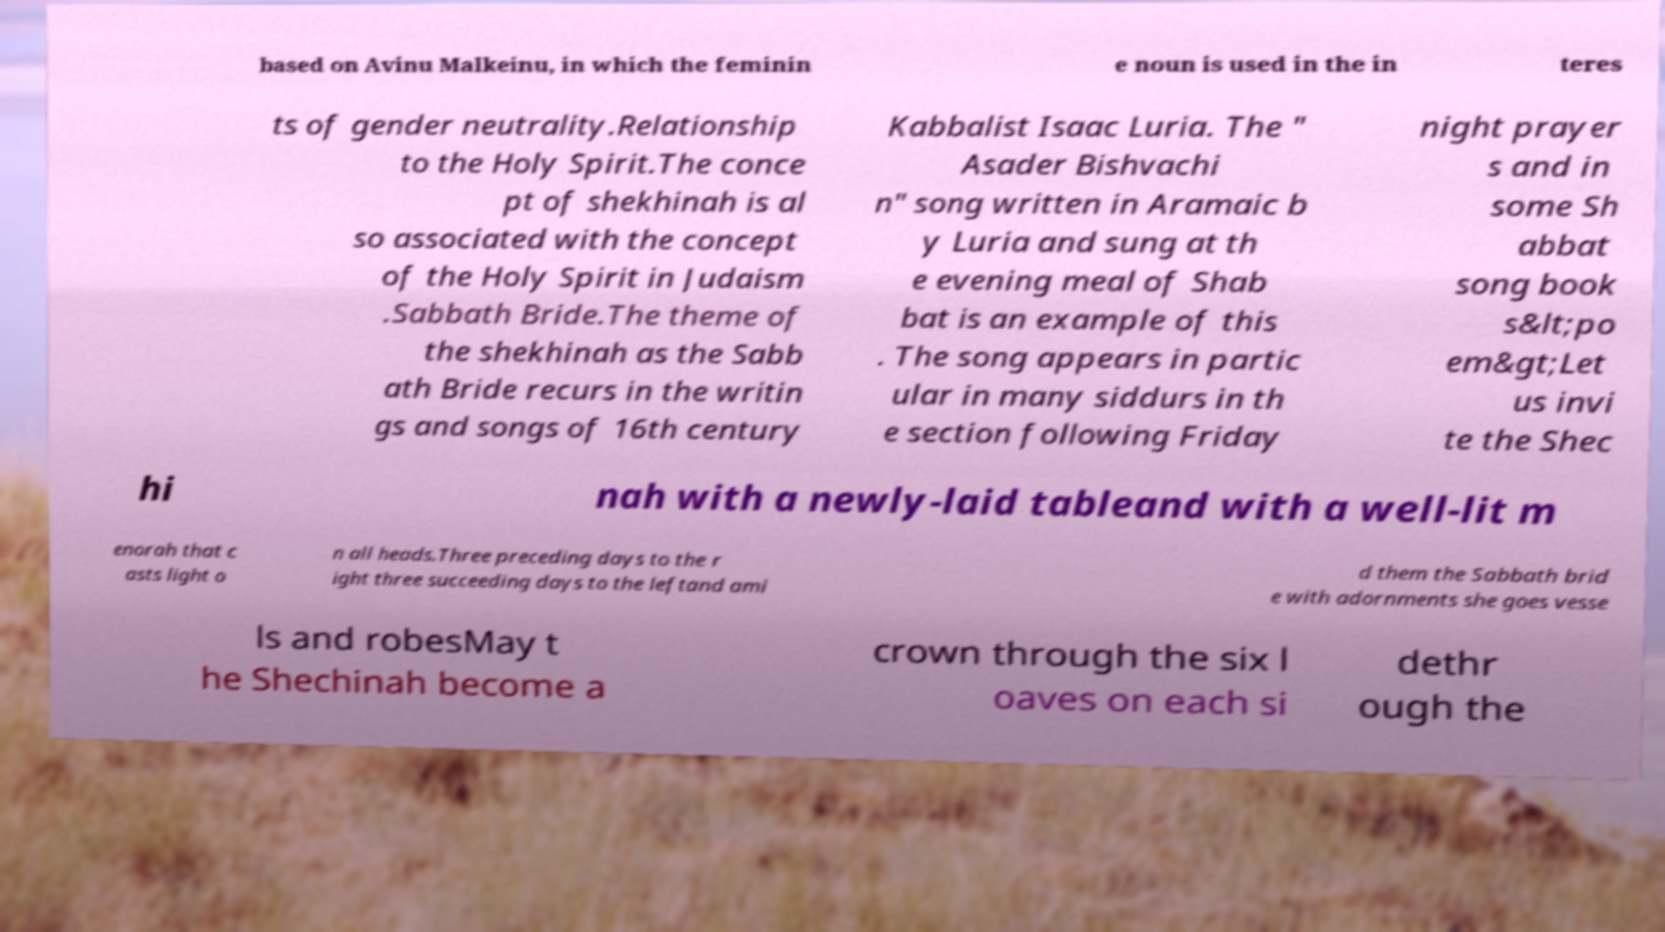Please identify and transcribe the text found in this image. based on Avinu Malkeinu, in which the feminin e noun is used in the in teres ts of gender neutrality.Relationship to the Holy Spirit.The conce pt of shekhinah is al so associated with the concept of the Holy Spirit in Judaism .Sabbath Bride.The theme of the shekhinah as the Sabb ath Bride recurs in the writin gs and songs of 16th century Kabbalist Isaac Luria. The " Asader Bishvachi n" song written in Aramaic b y Luria and sung at th e evening meal of Shab bat is an example of this . The song appears in partic ular in many siddurs in th e section following Friday night prayer s and in some Sh abbat song book s&lt;po em&gt;Let us invi te the Shec hi nah with a newly-laid tableand with a well-lit m enorah that c asts light o n all heads.Three preceding days to the r ight three succeeding days to the leftand ami d them the Sabbath brid e with adornments she goes vesse ls and robesMay t he Shechinah become a crown through the six l oaves on each si dethr ough the 